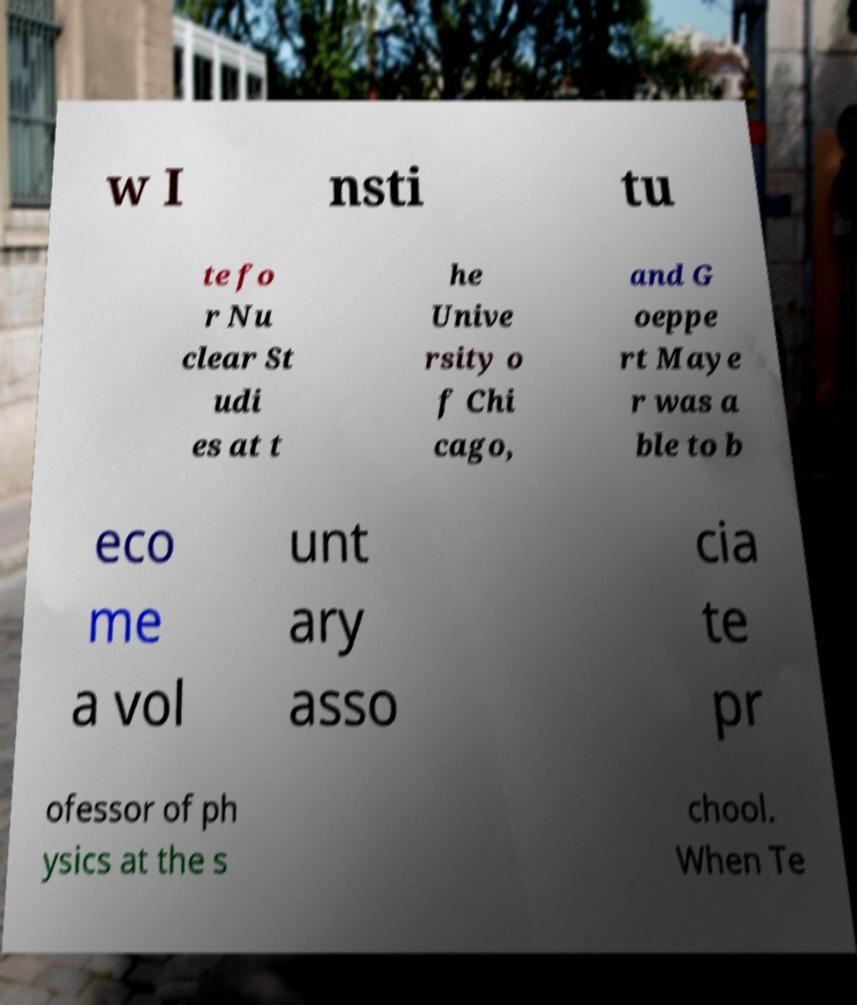For documentation purposes, I need the text within this image transcribed. Could you provide that? w I nsti tu te fo r Nu clear St udi es at t he Unive rsity o f Chi cago, and G oeppe rt Maye r was a ble to b eco me a vol unt ary asso cia te pr ofessor of ph ysics at the s chool. When Te 